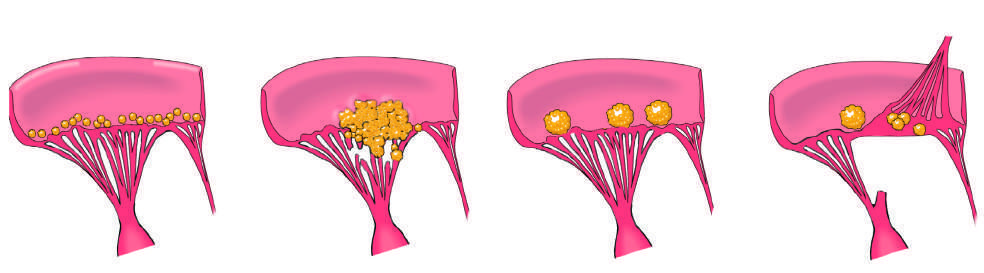what does non-bacterial thrombotic endocarditis manifest with?
Answer the question using a single word or phrase. Small- to medium-sized 